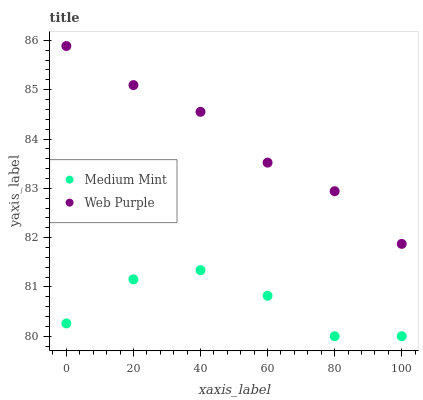Does Medium Mint have the minimum area under the curve?
Answer yes or no. Yes. Does Web Purple have the maximum area under the curve?
Answer yes or no. Yes. Does Web Purple have the minimum area under the curve?
Answer yes or no. No. Is Web Purple the smoothest?
Answer yes or no. Yes. Is Medium Mint the roughest?
Answer yes or no. Yes. Is Web Purple the roughest?
Answer yes or no. No. Does Medium Mint have the lowest value?
Answer yes or no. Yes. Does Web Purple have the lowest value?
Answer yes or no. No. Does Web Purple have the highest value?
Answer yes or no. Yes. Is Medium Mint less than Web Purple?
Answer yes or no. Yes. Is Web Purple greater than Medium Mint?
Answer yes or no. Yes. Does Medium Mint intersect Web Purple?
Answer yes or no. No. 